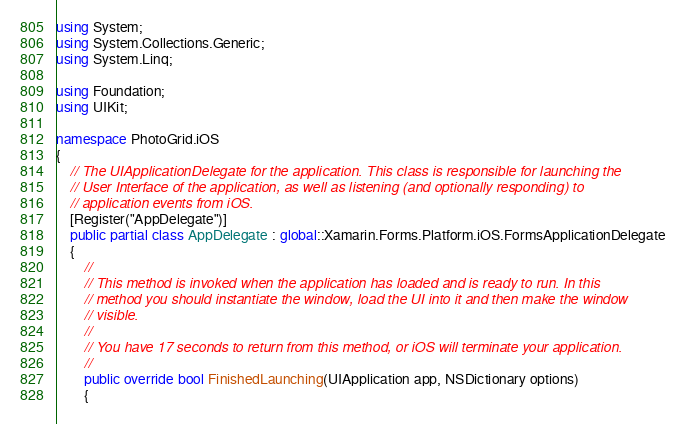Convert code to text. <code><loc_0><loc_0><loc_500><loc_500><_C#_>using System;
using System.Collections.Generic;
using System.Linq;

using Foundation;
using UIKit;

namespace PhotoGrid.iOS
{
    // The UIApplicationDelegate for the application. This class is responsible for launching the 
    // User Interface of the application, as well as listening (and optionally responding) to 
    // application events from iOS.
    [Register("AppDelegate")]
    public partial class AppDelegate : global::Xamarin.Forms.Platform.iOS.FormsApplicationDelegate
    {
        //
        // This method is invoked when the application has loaded and is ready to run. In this 
        // method you should instantiate the window, load the UI into it and then make the window
        // visible.
        //
        // You have 17 seconds to return from this method, or iOS will terminate your application.
        //
        public override bool FinishedLaunching(UIApplication app, NSDictionary options)
        {</code> 